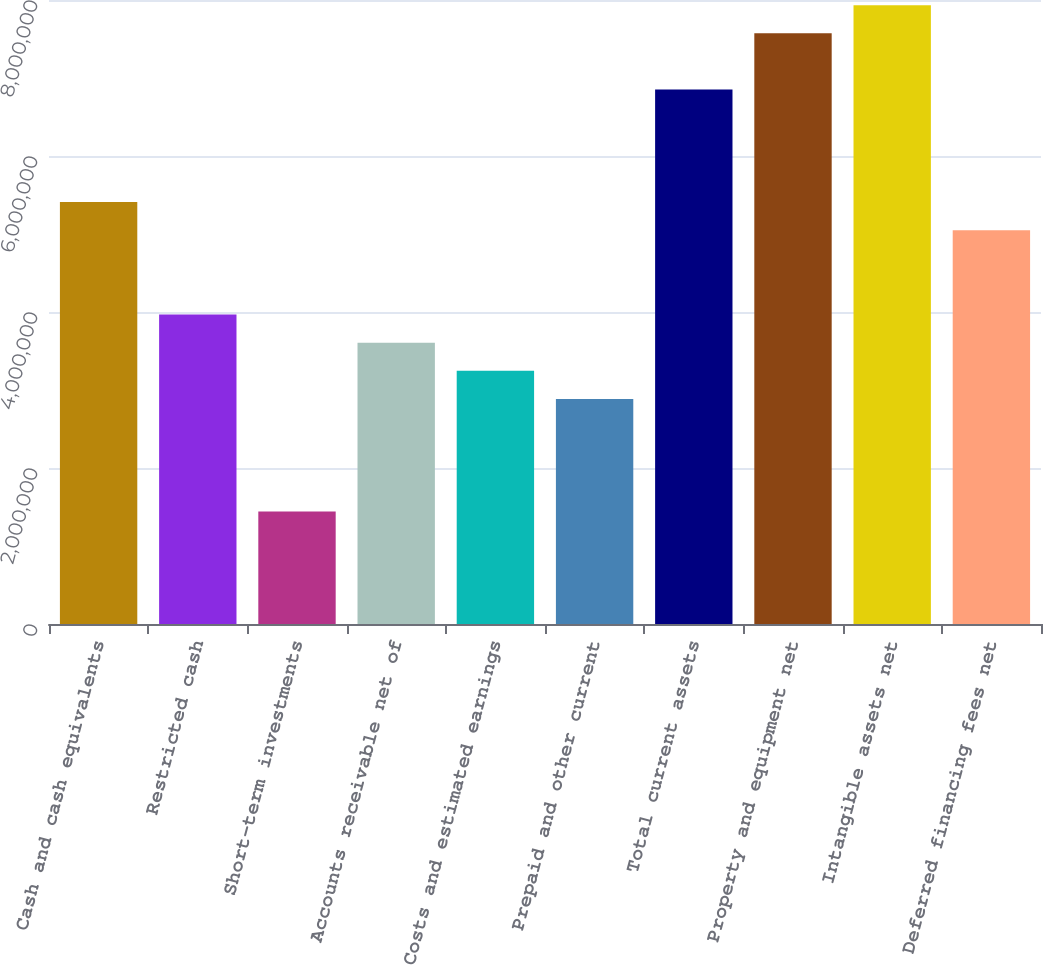Convert chart. <chart><loc_0><loc_0><loc_500><loc_500><bar_chart><fcel>Cash and cash equivalents<fcel>Restricted cash<fcel>Short-term investments<fcel>Accounts receivable net of<fcel>Costs and estimated earnings<fcel>Prepaid and other current<fcel>Total current assets<fcel>Property and equipment net<fcel>Intangible assets net<fcel>Deferred financing fees net<nl><fcel>5.40936e+06<fcel>3.96699e+06<fcel>1.44285e+06<fcel>3.6064e+06<fcel>3.24581e+06<fcel>2.88522e+06<fcel>6.85172e+06<fcel>7.5729e+06<fcel>7.9335e+06<fcel>5.04876e+06<nl></chart> 